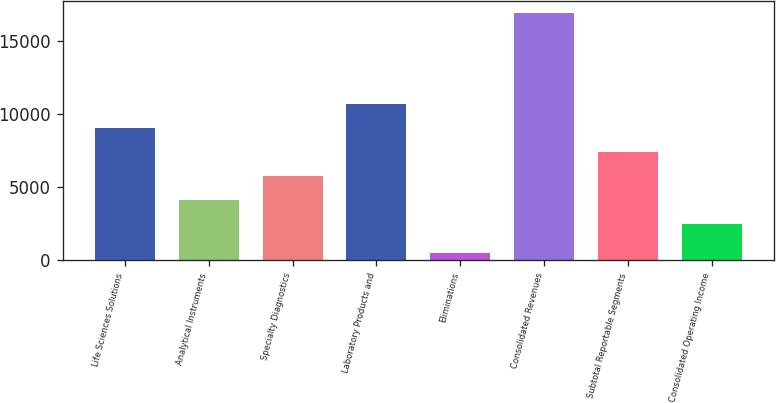Convert chart to OTSL. <chart><loc_0><loc_0><loc_500><loc_500><bar_chart><fcel>Life Sciences Solutions<fcel>Analytical Instruments<fcel>Specialty Diagnostics<fcel>Laboratory Products and<fcel>Eliminations<fcel>Consolidated Revenues<fcel>Subtotal Reportable Segments<fcel>Consolidated Operating Income<nl><fcel>9057.48<fcel>4141.62<fcel>5780.24<fcel>10696.1<fcel>503.4<fcel>16889.6<fcel>7418.86<fcel>2503<nl></chart> 